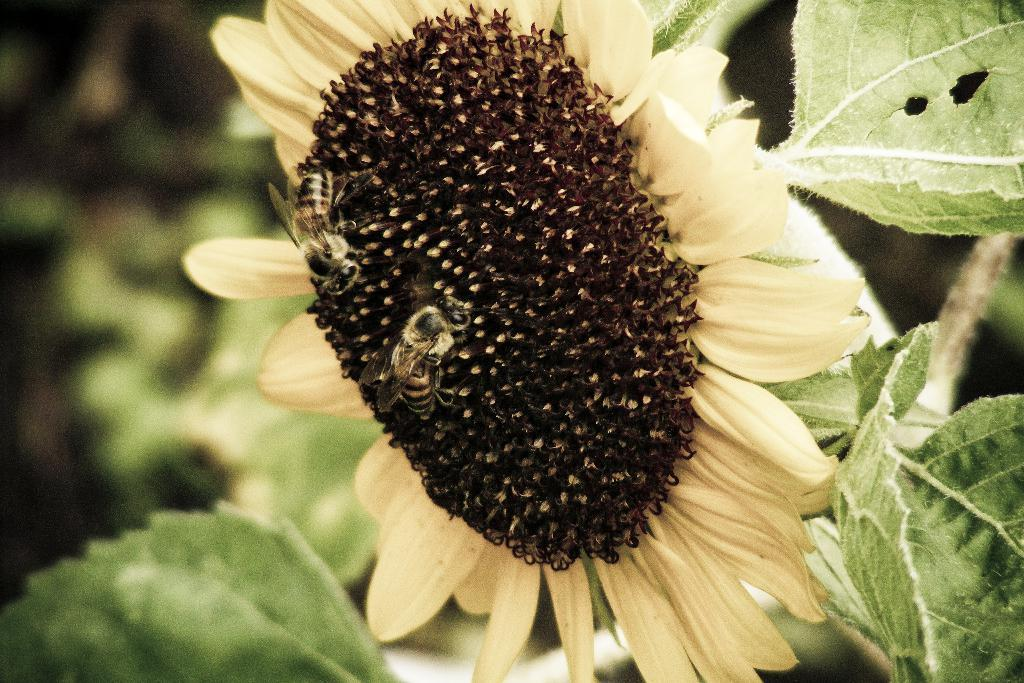What type of plant is featured in the image? There is a sunflower in the image. What color are the leaves of the plant? There are green leaves in the image. Are there any insects present on the sunflower? Yes, honey bees are present on the sunflower. What type of team is visible in the image? There is no team present in the image; it features a sunflower with green leaves and honey bees. Can you tell me how many roses are in the image? There are no roses in the image; it features a sunflower. 